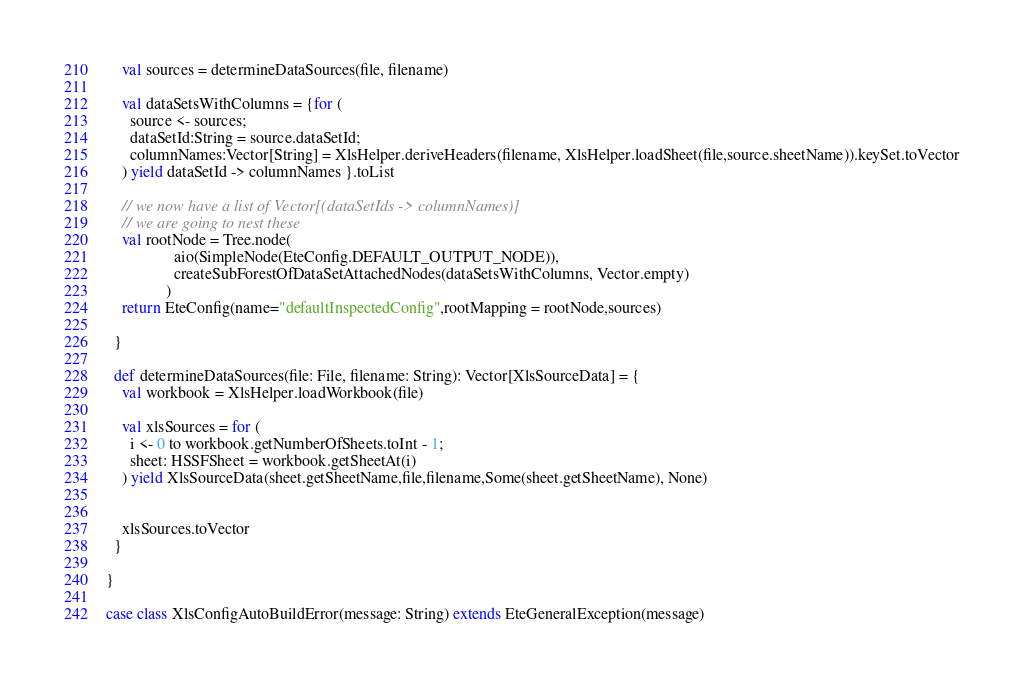<code> <loc_0><loc_0><loc_500><loc_500><_Scala_>    val sources = determineDataSources(file, filename)

    val dataSetsWithColumns = {for (
      source <- sources;
      dataSetId:String = source.dataSetId;
      columnNames:Vector[String] = XlsHelper.deriveHeaders(filename, XlsHelper.loadSheet(file,source.sheetName)).keySet.toVector
    ) yield dataSetId -> columnNames }.toList

    // we now have a list of Vector[(dataSetIds -> columnNames)]
    // we are going to nest these
    val rootNode = Tree.node(
                 aio(SimpleNode(EteConfig.DEFAULT_OUTPUT_NODE)),
                 createSubForestOfDataSetAttachedNodes(dataSetsWithColumns, Vector.empty)
               )
    return EteConfig(name="defaultInspectedConfig",rootMapping = rootNode,sources)

  }

  def determineDataSources(file: File, filename: String): Vector[XlsSourceData] = {
    val workbook = XlsHelper.loadWorkbook(file)

    val xlsSources = for (
      i <- 0 to workbook.getNumberOfSheets.toInt - 1;
      sheet: HSSFSheet = workbook.getSheetAt(i)
    ) yield XlsSourceData(sheet.getSheetName,file,filename,Some(sheet.getSheetName), None)


    xlsSources.toVector
  }

}

case class XlsConfigAutoBuildError(message: String) extends EteGeneralException(message)
</code> 